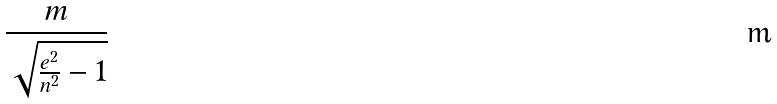Convert formula to latex. <formula><loc_0><loc_0><loc_500><loc_500>\frac { m } { \sqrt { \frac { e ^ { 2 } } { n ^ { 2 } } - 1 } }</formula> 